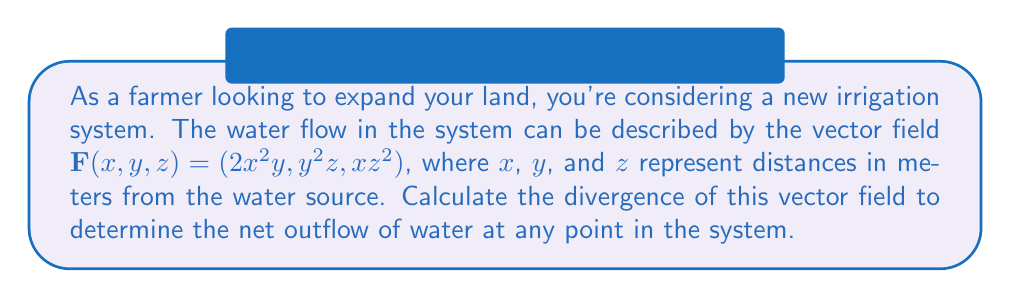What is the answer to this math problem? To solve this problem, we need to compute the divergence of the given vector field. The divergence is a scalar quantity that measures the net outflow of a vector field from an infinitesimal volume around any point.

For a vector field $\mathbf{F}(x,y,z) = (F_x, F_y, F_z)$, the divergence is given by:

$$\text{div}\mathbf{F} = \nabla \cdot \mathbf{F} = \frac{\partial F_x}{\partial x} + \frac{\partial F_y}{\partial y} + \frac{\partial F_z}{\partial z}$$

Let's break it down step by step:

1) First, we identify the components of our vector field:
   $F_x = 2x^2y$
   $F_y = y^2z$
   $F_z = xz^2$

2) Now, we calculate the partial derivatives:
   $\frac{\partial F_x}{\partial x} = \frac{\partial}{\partial x}(2x^2y) = 4xy$
   $\frac{\partial F_y}{\partial y} = \frac{\partial}{\partial y}(y^2z) = 2yz$
   $\frac{\partial F_z}{\partial z} = \frac{\partial}{\partial z}(xz^2) = 2xz$

3) Finally, we sum these partial derivatives:
   $\text{div}\mathbf{F} = \frac{\partial F_x}{\partial x} + \frac{\partial F_y}{\partial y} + \frac{\partial F_z}{\partial z}$
   $= 4xy + 2yz + 2xz$

This result represents the net outflow of water at any point $(x,y,z)$ in the irrigation system.
Answer: $4xy + 2yz + 2xz$ 